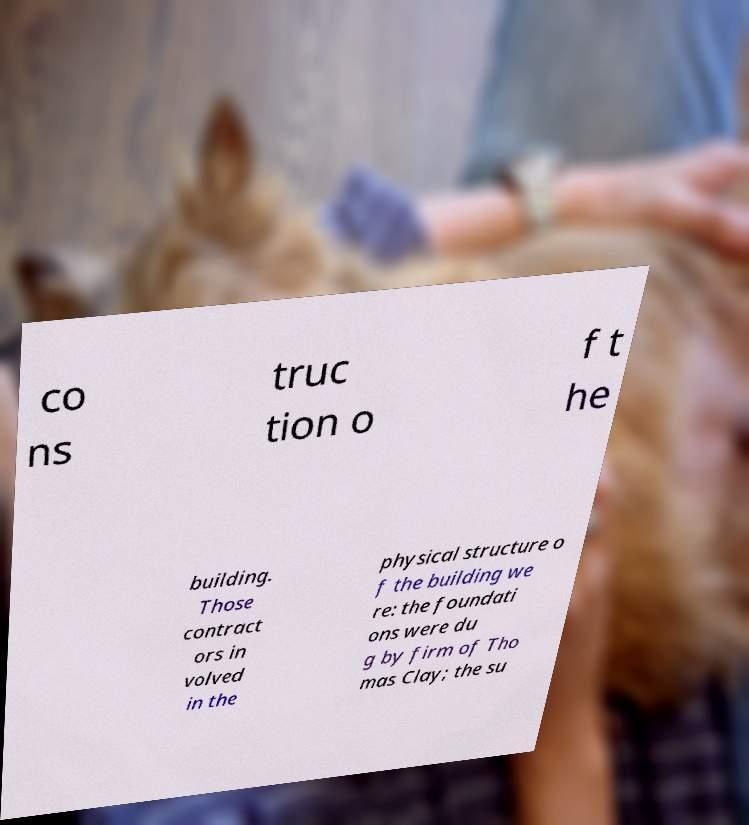Please read and relay the text visible in this image. What does it say? co ns truc tion o f t he building. Those contract ors in volved in the physical structure o f the building we re: the foundati ons were du g by firm of Tho mas Clay; the su 